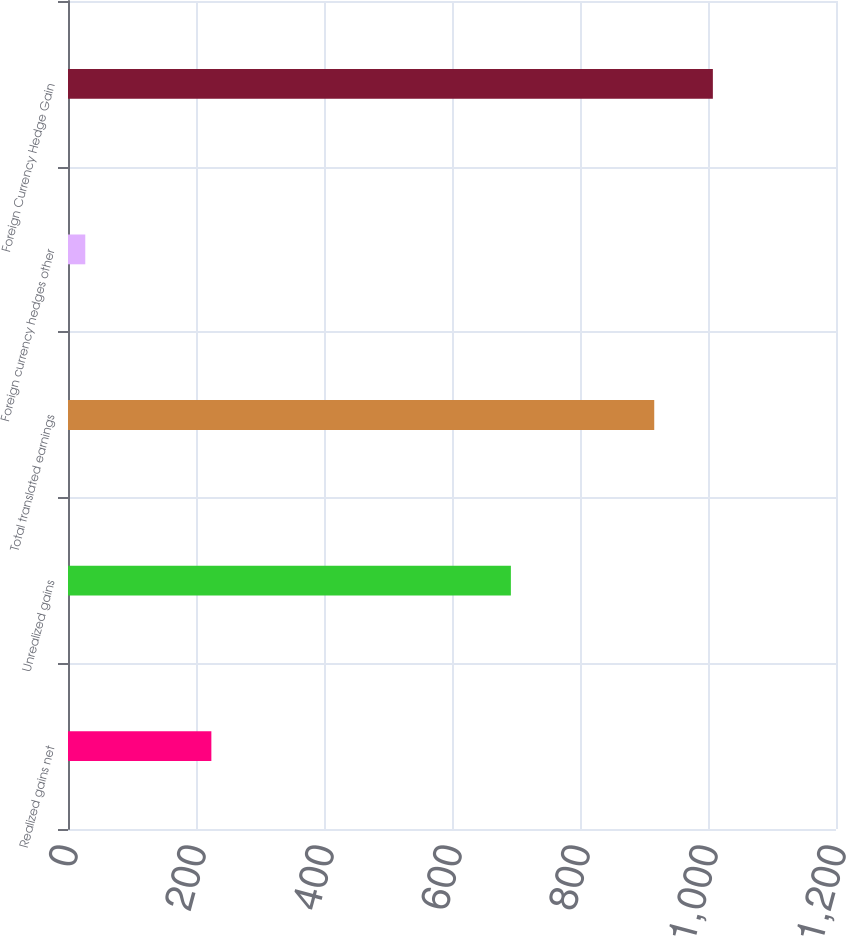<chart> <loc_0><loc_0><loc_500><loc_500><bar_chart><fcel>Realized gains net<fcel>Unrealized gains<fcel>Total translated earnings<fcel>Foreign currency hedges other<fcel>Foreign Currency Hedge Gain<nl><fcel>224<fcel>692<fcel>916<fcel>27<fcel>1007.6<nl></chart> 